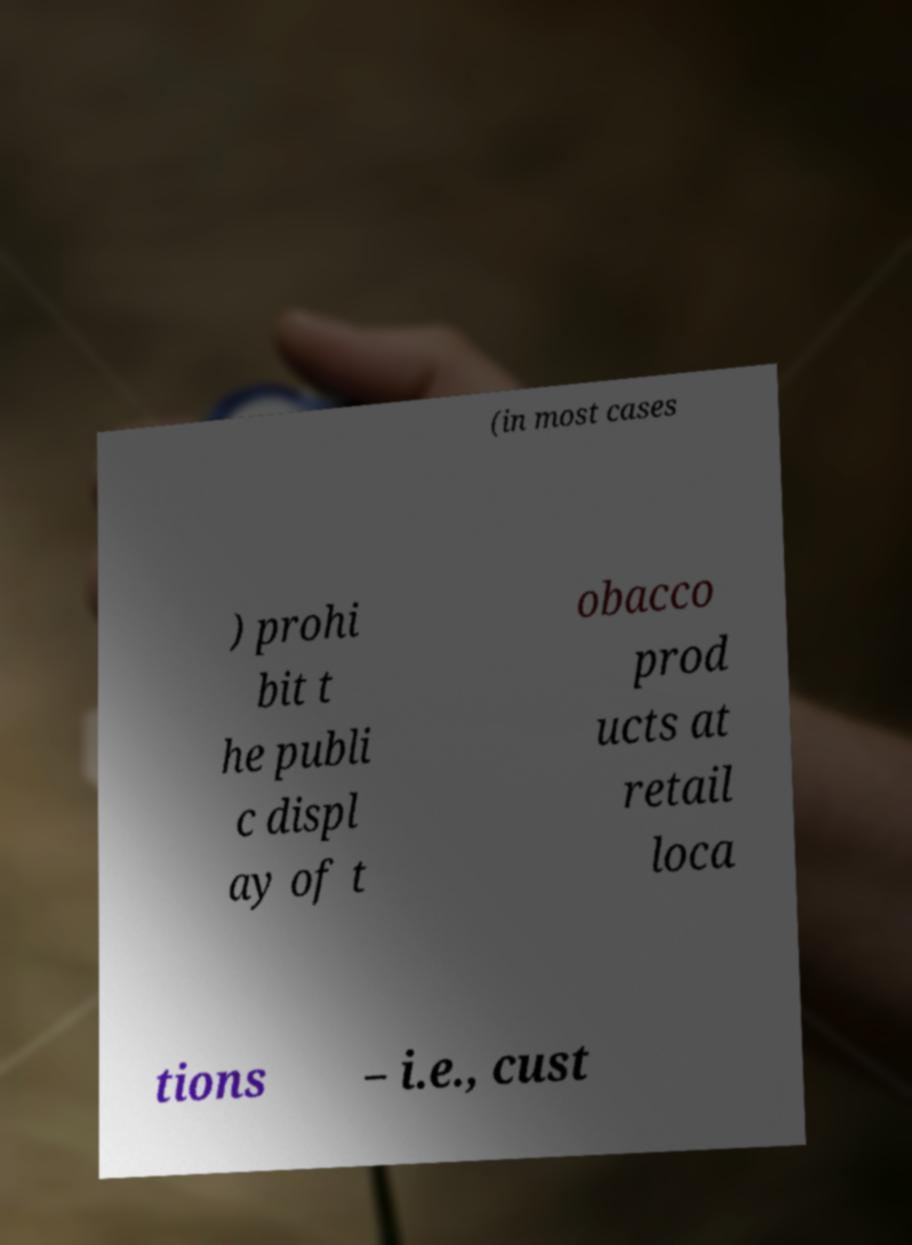I need the written content from this picture converted into text. Can you do that? (in most cases ) prohi bit t he publi c displ ay of t obacco prod ucts at retail loca tions – i.e., cust 